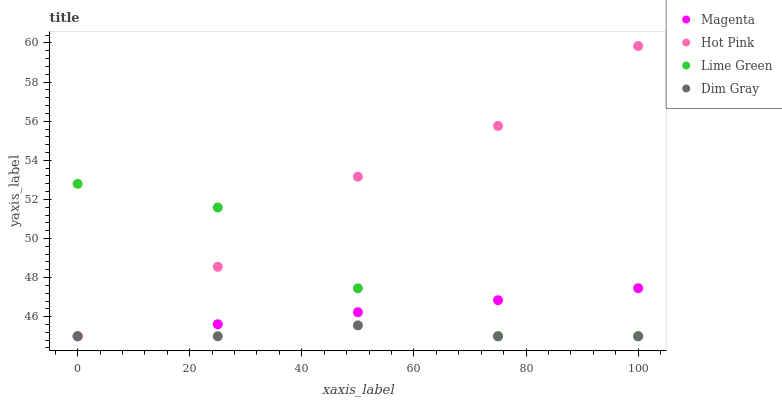Does Dim Gray have the minimum area under the curve?
Answer yes or no. Yes. Does Hot Pink have the maximum area under the curve?
Answer yes or no. Yes. Does Lime Green have the minimum area under the curve?
Answer yes or no. No. Does Lime Green have the maximum area under the curve?
Answer yes or no. No. Is Magenta the smoothest?
Answer yes or no. Yes. Is Lime Green the roughest?
Answer yes or no. Yes. Is Hot Pink the smoothest?
Answer yes or no. No. Is Hot Pink the roughest?
Answer yes or no. No. Does Magenta have the lowest value?
Answer yes or no. Yes. Does Hot Pink have the highest value?
Answer yes or no. Yes. Does Lime Green have the highest value?
Answer yes or no. No. Does Magenta intersect Dim Gray?
Answer yes or no. Yes. Is Magenta less than Dim Gray?
Answer yes or no. No. Is Magenta greater than Dim Gray?
Answer yes or no. No. 